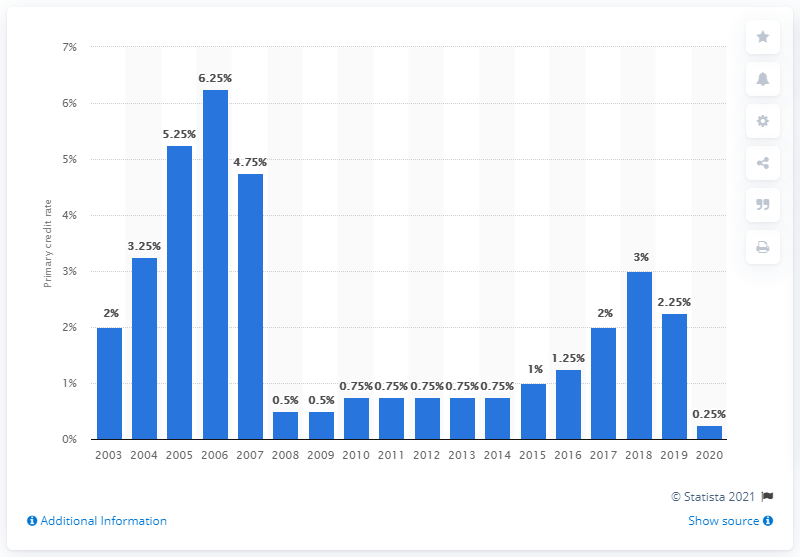Indicate a few pertinent items in this graphic. At the end of 2020, the primary credit rate in the United States was 0.25%. 